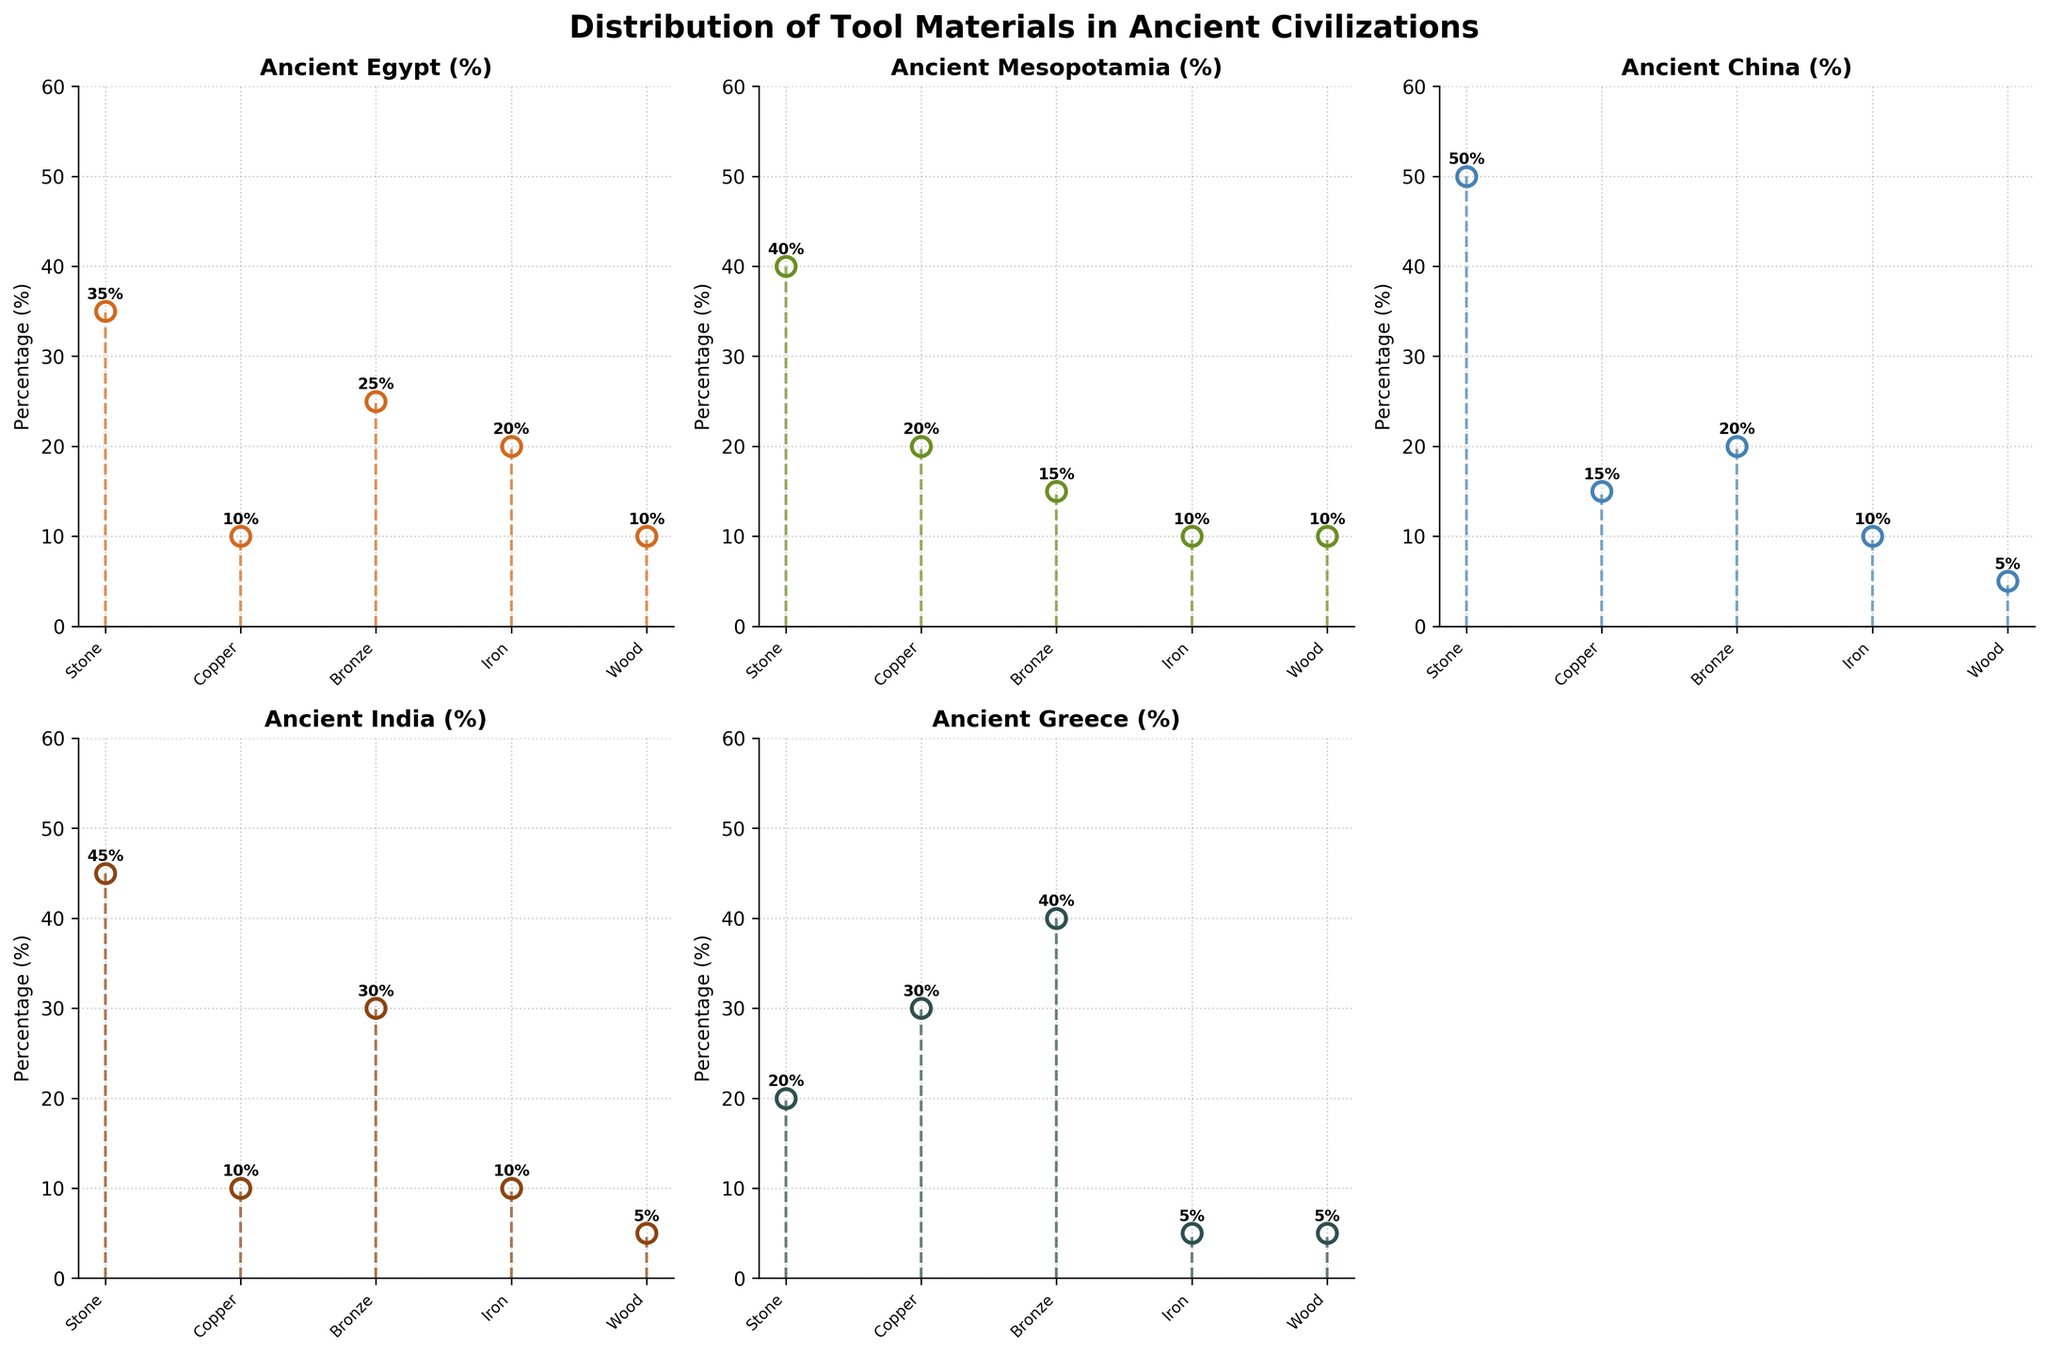Which civilization used stone the most? By examining the plot, we see that Ancient China has the highest percentage for stone at 50%.
Answer: Ancient China Which material was least used by Ancient Mesopotamia? The materials and their corresponding percentages for Ancient Mesopotamia are: Stone (40%), Copper (20%), Bronze (15%), Iron (10%), and Wood (10%). The least used materials are Iron and Wood, both at 10%.
Answer: Iron and Wood What is the average percentage of wood usage across all civilizations? The percentages of wood usage are: 10%, 10%, 5%, 5%, and 5%. Adding these together (10 + 10 + 5 + 5 + 5) = 35, and dividing by the number of civilizations (5), the average is 35/5 = 7%.
Answer: 7% Compare the usage of iron between Ancient Greece and Ancient Mesopotamia. From the plot, Ancient Greece used iron at 5%, while Ancient Mesopotamia used it at 10%. Therefore, the usage of iron is higher in Ancient Mesopotamia.
Answer: Ancient Mesopotamia Which civilization has the highest percentage of material other than stone? From the plot, Ancient Greece's usage of bronze stands out at 40%, which is the highest percentage among non-stone materials.
Answer: Ancient Greece Sum the total percentage of copper and bronze usage in Ancient Egypt. From the plot, Ancient Egypt's percentages for copper and bronze are 10% and 25%, respectively. Adding these together (10 + 25) = 35%.
Answer: 35% In which civilizations does stone account for over 40% of the tools? The plot shows that Ancient Mesopotamia (40%), Ancient China (50%), and Ancient India (45%) have stone usage over 40%.
Answer: Ancient Mesopotamia, Ancient China, Ancient India What is the percentage difference in bronze usage between Ancient India and Ancient Mesopotamia? From the plot, Ancient India uses bronze at 30% and Ancient Mesopotamia at 15%. The difference is 30 - 15 = 15%.
Answer: 15% How does the usage of copper in Ancient Greece compare to Ancient Egypt? The plot shows Ancient Greece with 30% copper usage, while Ancient Egypt has 10%. Hence, Ancient Greece uses more copper than Ancient Egypt.
Answer: Ancient Greece Which material is least used overall across all civilizations? From the plot, wood appears consistently lower across all subplots, with percentages of 10%, 10%, 5%, 5%, and 5%. Therefore, wood is the least used material overall.
Answer: Wood 